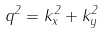<formula> <loc_0><loc_0><loc_500><loc_500>q ^ { 2 } = k _ { x } ^ { 2 } + k _ { y } ^ { 2 }</formula> 